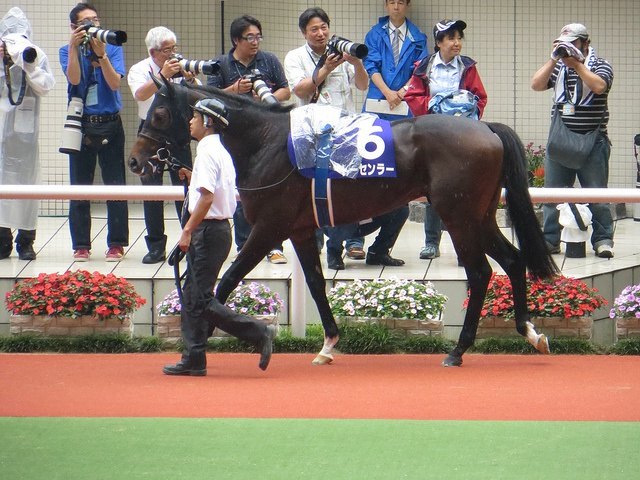Describe the objects in this image and their specific colors. I can see horse in darkgray, black, gray, and white tones, people in darkgray, black, white, gray, and brown tones, people in darkgray, gray, black, purple, and lightgray tones, people in darkgray, black, navy, and gray tones, and people in darkgray, lightgray, black, and gray tones in this image. 